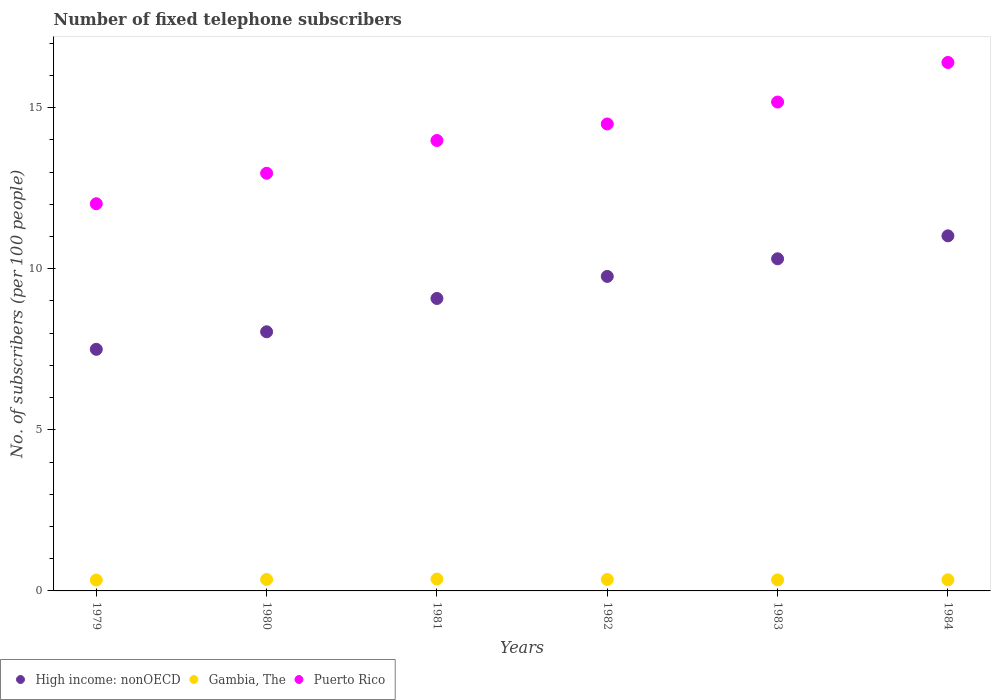Is the number of dotlines equal to the number of legend labels?
Your response must be concise. Yes. What is the number of fixed telephone subscribers in High income: nonOECD in 1979?
Your answer should be compact. 7.5. Across all years, what is the maximum number of fixed telephone subscribers in High income: nonOECD?
Your response must be concise. 11.02. Across all years, what is the minimum number of fixed telephone subscribers in Gambia, The?
Offer a very short reply. 0.34. In which year was the number of fixed telephone subscribers in Puerto Rico minimum?
Make the answer very short. 1979. What is the total number of fixed telephone subscribers in High income: nonOECD in the graph?
Provide a succinct answer. 55.71. What is the difference between the number of fixed telephone subscribers in High income: nonOECD in 1981 and that in 1983?
Your answer should be compact. -1.23. What is the difference between the number of fixed telephone subscribers in Gambia, The in 1979 and the number of fixed telephone subscribers in Puerto Rico in 1983?
Your answer should be compact. -14.83. What is the average number of fixed telephone subscribers in High income: nonOECD per year?
Your answer should be compact. 9.28. In the year 1980, what is the difference between the number of fixed telephone subscribers in High income: nonOECD and number of fixed telephone subscribers in Puerto Rico?
Give a very brief answer. -4.92. In how many years, is the number of fixed telephone subscribers in Puerto Rico greater than 9?
Your response must be concise. 6. What is the ratio of the number of fixed telephone subscribers in High income: nonOECD in 1979 to that in 1982?
Provide a short and direct response. 0.77. Is the number of fixed telephone subscribers in Gambia, The in 1979 less than that in 1982?
Ensure brevity in your answer.  Yes. Is the difference between the number of fixed telephone subscribers in High income: nonOECD in 1979 and 1982 greater than the difference between the number of fixed telephone subscribers in Puerto Rico in 1979 and 1982?
Give a very brief answer. Yes. What is the difference between the highest and the second highest number of fixed telephone subscribers in Puerto Rico?
Offer a very short reply. 1.23. What is the difference between the highest and the lowest number of fixed telephone subscribers in Gambia, The?
Make the answer very short. 0.03. In how many years, is the number of fixed telephone subscribers in Puerto Rico greater than the average number of fixed telephone subscribers in Puerto Rico taken over all years?
Provide a short and direct response. 3. Is the sum of the number of fixed telephone subscribers in High income: nonOECD in 1980 and 1984 greater than the maximum number of fixed telephone subscribers in Puerto Rico across all years?
Offer a very short reply. Yes. Is it the case that in every year, the sum of the number of fixed telephone subscribers in Gambia, The and number of fixed telephone subscribers in High income: nonOECD  is greater than the number of fixed telephone subscribers in Puerto Rico?
Offer a terse response. No. Does the number of fixed telephone subscribers in Puerto Rico monotonically increase over the years?
Provide a short and direct response. Yes. How many years are there in the graph?
Keep it short and to the point. 6. What is the difference between two consecutive major ticks on the Y-axis?
Ensure brevity in your answer.  5. Does the graph contain any zero values?
Your answer should be compact. No. Where does the legend appear in the graph?
Keep it short and to the point. Bottom left. How are the legend labels stacked?
Provide a succinct answer. Horizontal. What is the title of the graph?
Provide a succinct answer. Number of fixed telephone subscribers. What is the label or title of the X-axis?
Ensure brevity in your answer.  Years. What is the label or title of the Y-axis?
Offer a very short reply. No. of subscribers (per 100 people). What is the No. of subscribers (per 100 people) of High income: nonOECD in 1979?
Provide a succinct answer. 7.5. What is the No. of subscribers (per 100 people) in Gambia, The in 1979?
Your response must be concise. 0.34. What is the No. of subscribers (per 100 people) of Puerto Rico in 1979?
Ensure brevity in your answer.  12.02. What is the No. of subscribers (per 100 people) of High income: nonOECD in 1980?
Ensure brevity in your answer.  8.04. What is the No. of subscribers (per 100 people) of Gambia, The in 1980?
Your answer should be compact. 0.36. What is the No. of subscribers (per 100 people) of Puerto Rico in 1980?
Your answer should be very brief. 12.96. What is the No. of subscribers (per 100 people) of High income: nonOECD in 1981?
Your answer should be compact. 9.08. What is the No. of subscribers (per 100 people) in Gambia, The in 1981?
Your answer should be very brief. 0.37. What is the No. of subscribers (per 100 people) of Puerto Rico in 1981?
Your answer should be very brief. 13.98. What is the No. of subscribers (per 100 people) of High income: nonOECD in 1982?
Your answer should be very brief. 9.76. What is the No. of subscribers (per 100 people) in Gambia, The in 1982?
Offer a very short reply. 0.35. What is the No. of subscribers (per 100 people) of Puerto Rico in 1982?
Keep it short and to the point. 14.49. What is the No. of subscribers (per 100 people) in High income: nonOECD in 1983?
Ensure brevity in your answer.  10.31. What is the No. of subscribers (per 100 people) of Gambia, The in 1983?
Provide a succinct answer. 0.34. What is the No. of subscribers (per 100 people) of Puerto Rico in 1983?
Give a very brief answer. 15.17. What is the No. of subscribers (per 100 people) in High income: nonOECD in 1984?
Your answer should be compact. 11.02. What is the No. of subscribers (per 100 people) of Gambia, The in 1984?
Ensure brevity in your answer.  0.35. What is the No. of subscribers (per 100 people) of Puerto Rico in 1984?
Your answer should be compact. 16.4. Across all years, what is the maximum No. of subscribers (per 100 people) in High income: nonOECD?
Provide a short and direct response. 11.02. Across all years, what is the maximum No. of subscribers (per 100 people) of Gambia, The?
Offer a terse response. 0.37. Across all years, what is the maximum No. of subscribers (per 100 people) of Puerto Rico?
Your response must be concise. 16.4. Across all years, what is the minimum No. of subscribers (per 100 people) of High income: nonOECD?
Provide a succinct answer. 7.5. Across all years, what is the minimum No. of subscribers (per 100 people) of Gambia, The?
Provide a succinct answer. 0.34. Across all years, what is the minimum No. of subscribers (per 100 people) in Puerto Rico?
Offer a terse response. 12.02. What is the total No. of subscribers (per 100 people) in High income: nonOECD in the graph?
Make the answer very short. 55.71. What is the total No. of subscribers (per 100 people) in Gambia, The in the graph?
Provide a succinct answer. 2.1. What is the total No. of subscribers (per 100 people) in Puerto Rico in the graph?
Keep it short and to the point. 85.02. What is the difference between the No. of subscribers (per 100 people) of High income: nonOECD in 1979 and that in 1980?
Ensure brevity in your answer.  -0.54. What is the difference between the No. of subscribers (per 100 people) of Gambia, The in 1979 and that in 1980?
Keep it short and to the point. -0.02. What is the difference between the No. of subscribers (per 100 people) of Puerto Rico in 1979 and that in 1980?
Provide a succinct answer. -0.95. What is the difference between the No. of subscribers (per 100 people) of High income: nonOECD in 1979 and that in 1981?
Ensure brevity in your answer.  -1.58. What is the difference between the No. of subscribers (per 100 people) in Gambia, The in 1979 and that in 1981?
Keep it short and to the point. -0.03. What is the difference between the No. of subscribers (per 100 people) of Puerto Rico in 1979 and that in 1981?
Keep it short and to the point. -1.96. What is the difference between the No. of subscribers (per 100 people) of High income: nonOECD in 1979 and that in 1982?
Give a very brief answer. -2.26. What is the difference between the No. of subscribers (per 100 people) of Gambia, The in 1979 and that in 1982?
Ensure brevity in your answer.  -0.02. What is the difference between the No. of subscribers (per 100 people) in Puerto Rico in 1979 and that in 1982?
Your response must be concise. -2.48. What is the difference between the No. of subscribers (per 100 people) of High income: nonOECD in 1979 and that in 1983?
Your answer should be very brief. -2.81. What is the difference between the No. of subscribers (per 100 people) of Gambia, The in 1979 and that in 1983?
Your response must be concise. -0. What is the difference between the No. of subscribers (per 100 people) of Puerto Rico in 1979 and that in 1983?
Ensure brevity in your answer.  -3.16. What is the difference between the No. of subscribers (per 100 people) of High income: nonOECD in 1979 and that in 1984?
Make the answer very short. -3.52. What is the difference between the No. of subscribers (per 100 people) in Gambia, The in 1979 and that in 1984?
Provide a short and direct response. -0.01. What is the difference between the No. of subscribers (per 100 people) in Puerto Rico in 1979 and that in 1984?
Your answer should be very brief. -4.38. What is the difference between the No. of subscribers (per 100 people) of High income: nonOECD in 1980 and that in 1981?
Ensure brevity in your answer.  -1.03. What is the difference between the No. of subscribers (per 100 people) of Gambia, The in 1980 and that in 1981?
Make the answer very short. -0.01. What is the difference between the No. of subscribers (per 100 people) of Puerto Rico in 1980 and that in 1981?
Give a very brief answer. -1.02. What is the difference between the No. of subscribers (per 100 people) of High income: nonOECD in 1980 and that in 1982?
Keep it short and to the point. -1.72. What is the difference between the No. of subscribers (per 100 people) of Gambia, The in 1980 and that in 1982?
Your answer should be very brief. 0. What is the difference between the No. of subscribers (per 100 people) of Puerto Rico in 1980 and that in 1982?
Your answer should be very brief. -1.53. What is the difference between the No. of subscribers (per 100 people) of High income: nonOECD in 1980 and that in 1983?
Ensure brevity in your answer.  -2.27. What is the difference between the No. of subscribers (per 100 people) of Gambia, The in 1980 and that in 1983?
Offer a very short reply. 0.01. What is the difference between the No. of subscribers (per 100 people) in Puerto Rico in 1980 and that in 1983?
Keep it short and to the point. -2.21. What is the difference between the No. of subscribers (per 100 people) in High income: nonOECD in 1980 and that in 1984?
Keep it short and to the point. -2.98. What is the difference between the No. of subscribers (per 100 people) in Gambia, The in 1980 and that in 1984?
Offer a terse response. 0.01. What is the difference between the No. of subscribers (per 100 people) of Puerto Rico in 1980 and that in 1984?
Offer a very short reply. -3.44. What is the difference between the No. of subscribers (per 100 people) in High income: nonOECD in 1981 and that in 1982?
Ensure brevity in your answer.  -0.68. What is the difference between the No. of subscribers (per 100 people) of Gambia, The in 1981 and that in 1982?
Offer a terse response. 0.01. What is the difference between the No. of subscribers (per 100 people) in Puerto Rico in 1981 and that in 1982?
Offer a terse response. -0.51. What is the difference between the No. of subscribers (per 100 people) of High income: nonOECD in 1981 and that in 1983?
Your response must be concise. -1.23. What is the difference between the No. of subscribers (per 100 people) of Gambia, The in 1981 and that in 1983?
Your answer should be compact. 0.03. What is the difference between the No. of subscribers (per 100 people) of Puerto Rico in 1981 and that in 1983?
Your response must be concise. -1.19. What is the difference between the No. of subscribers (per 100 people) in High income: nonOECD in 1981 and that in 1984?
Ensure brevity in your answer.  -1.94. What is the difference between the No. of subscribers (per 100 people) of Gambia, The in 1981 and that in 1984?
Offer a terse response. 0.02. What is the difference between the No. of subscribers (per 100 people) in Puerto Rico in 1981 and that in 1984?
Ensure brevity in your answer.  -2.42. What is the difference between the No. of subscribers (per 100 people) in High income: nonOECD in 1982 and that in 1983?
Provide a short and direct response. -0.55. What is the difference between the No. of subscribers (per 100 people) of Gambia, The in 1982 and that in 1983?
Your answer should be very brief. 0.01. What is the difference between the No. of subscribers (per 100 people) in Puerto Rico in 1982 and that in 1983?
Offer a terse response. -0.68. What is the difference between the No. of subscribers (per 100 people) in High income: nonOECD in 1982 and that in 1984?
Provide a short and direct response. -1.26. What is the difference between the No. of subscribers (per 100 people) of Gambia, The in 1982 and that in 1984?
Ensure brevity in your answer.  0.01. What is the difference between the No. of subscribers (per 100 people) of Puerto Rico in 1982 and that in 1984?
Keep it short and to the point. -1.91. What is the difference between the No. of subscribers (per 100 people) in High income: nonOECD in 1983 and that in 1984?
Ensure brevity in your answer.  -0.71. What is the difference between the No. of subscribers (per 100 people) in Gambia, The in 1983 and that in 1984?
Your response must be concise. -0. What is the difference between the No. of subscribers (per 100 people) in Puerto Rico in 1983 and that in 1984?
Offer a very short reply. -1.23. What is the difference between the No. of subscribers (per 100 people) of High income: nonOECD in 1979 and the No. of subscribers (per 100 people) of Gambia, The in 1980?
Keep it short and to the point. 7.14. What is the difference between the No. of subscribers (per 100 people) in High income: nonOECD in 1979 and the No. of subscribers (per 100 people) in Puerto Rico in 1980?
Your answer should be very brief. -5.46. What is the difference between the No. of subscribers (per 100 people) in Gambia, The in 1979 and the No. of subscribers (per 100 people) in Puerto Rico in 1980?
Provide a succinct answer. -12.62. What is the difference between the No. of subscribers (per 100 people) in High income: nonOECD in 1979 and the No. of subscribers (per 100 people) in Gambia, The in 1981?
Offer a terse response. 7.13. What is the difference between the No. of subscribers (per 100 people) in High income: nonOECD in 1979 and the No. of subscribers (per 100 people) in Puerto Rico in 1981?
Make the answer very short. -6.48. What is the difference between the No. of subscribers (per 100 people) of Gambia, The in 1979 and the No. of subscribers (per 100 people) of Puerto Rico in 1981?
Provide a short and direct response. -13.64. What is the difference between the No. of subscribers (per 100 people) of High income: nonOECD in 1979 and the No. of subscribers (per 100 people) of Gambia, The in 1982?
Provide a short and direct response. 7.14. What is the difference between the No. of subscribers (per 100 people) in High income: nonOECD in 1979 and the No. of subscribers (per 100 people) in Puerto Rico in 1982?
Provide a short and direct response. -6.99. What is the difference between the No. of subscribers (per 100 people) of Gambia, The in 1979 and the No. of subscribers (per 100 people) of Puerto Rico in 1982?
Ensure brevity in your answer.  -14.15. What is the difference between the No. of subscribers (per 100 people) in High income: nonOECD in 1979 and the No. of subscribers (per 100 people) in Gambia, The in 1983?
Your answer should be compact. 7.16. What is the difference between the No. of subscribers (per 100 people) of High income: nonOECD in 1979 and the No. of subscribers (per 100 people) of Puerto Rico in 1983?
Give a very brief answer. -7.67. What is the difference between the No. of subscribers (per 100 people) in Gambia, The in 1979 and the No. of subscribers (per 100 people) in Puerto Rico in 1983?
Make the answer very short. -14.83. What is the difference between the No. of subscribers (per 100 people) of High income: nonOECD in 1979 and the No. of subscribers (per 100 people) of Gambia, The in 1984?
Keep it short and to the point. 7.15. What is the difference between the No. of subscribers (per 100 people) in High income: nonOECD in 1979 and the No. of subscribers (per 100 people) in Puerto Rico in 1984?
Provide a succinct answer. -8.9. What is the difference between the No. of subscribers (per 100 people) of Gambia, The in 1979 and the No. of subscribers (per 100 people) of Puerto Rico in 1984?
Give a very brief answer. -16.06. What is the difference between the No. of subscribers (per 100 people) in High income: nonOECD in 1980 and the No. of subscribers (per 100 people) in Gambia, The in 1981?
Offer a terse response. 7.67. What is the difference between the No. of subscribers (per 100 people) of High income: nonOECD in 1980 and the No. of subscribers (per 100 people) of Puerto Rico in 1981?
Your response must be concise. -5.94. What is the difference between the No. of subscribers (per 100 people) in Gambia, The in 1980 and the No. of subscribers (per 100 people) in Puerto Rico in 1981?
Offer a very short reply. -13.62. What is the difference between the No. of subscribers (per 100 people) in High income: nonOECD in 1980 and the No. of subscribers (per 100 people) in Gambia, The in 1982?
Your answer should be very brief. 7.69. What is the difference between the No. of subscribers (per 100 people) in High income: nonOECD in 1980 and the No. of subscribers (per 100 people) in Puerto Rico in 1982?
Provide a short and direct response. -6.45. What is the difference between the No. of subscribers (per 100 people) of Gambia, The in 1980 and the No. of subscribers (per 100 people) of Puerto Rico in 1982?
Offer a very short reply. -14.14. What is the difference between the No. of subscribers (per 100 people) of High income: nonOECD in 1980 and the No. of subscribers (per 100 people) of Gambia, The in 1983?
Your response must be concise. 7.7. What is the difference between the No. of subscribers (per 100 people) of High income: nonOECD in 1980 and the No. of subscribers (per 100 people) of Puerto Rico in 1983?
Ensure brevity in your answer.  -7.13. What is the difference between the No. of subscribers (per 100 people) of Gambia, The in 1980 and the No. of subscribers (per 100 people) of Puerto Rico in 1983?
Ensure brevity in your answer.  -14.82. What is the difference between the No. of subscribers (per 100 people) in High income: nonOECD in 1980 and the No. of subscribers (per 100 people) in Gambia, The in 1984?
Provide a succinct answer. 7.7. What is the difference between the No. of subscribers (per 100 people) in High income: nonOECD in 1980 and the No. of subscribers (per 100 people) in Puerto Rico in 1984?
Provide a short and direct response. -8.36. What is the difference between the No. of subscribers (per 100 people) of Gambia, The in 1980 and the No. of subscribers (per 100 people) of Puerto Rico in 1984?
Give a very brief answer. -16.05. What is the difference between the No. of subscribers (per 100 people) of High income: nonOECD in 1981 and the No. of subscribers (per 100 people) of Gambia, The in 1982?
Provide a short and direct response. 8.72. What is the difference between the No. of subscribers (per 100 people) in High income: nonOECD in 1981 and the No. of subscribers (per 100 people) in Puerto Rico in 1982?
Give a very brief answer. -5.42. What is the difference between the No. of subscribers (per 100 people) of Gambia, The in 1981 and the No. of subscribers (per 100 people) of Puerto Rico in 1982?
Ensure brevity in your answer.  -14.12. What is the difference between the No. of subscribers (per 100 people) of High income: nonOECD in 1981 and the No. of subscribers (per 100 people) of Gambia, The in 1983?
Provide a succinct answer. 8.73. What is the difference between the No. of subscribers (per 100 people) of High income: nonOECD in 1981 and the No. of subscribers (per 100 people) of Puerto Rico in 1983?
Ensure brevity in your answer.  -6.1. What is the difference between the No. of subscribers (per 100 people) of Gambia, The in 1981 and the No. of subscribers (per 100 people) of Puerto Rico in 1983?
Provide a succinct answer. -14.8. What is the difference between the No. of subscribers (per 100 people) in High income: nonOECD in 1981 and the No. of subscribers (per 100 people) in Gambia, The in 1984?
Offer a terse response. 8.73. What is the difference between the No. of subscribers (per 100 people) in High income: nonOECD in 1981 and the No. of subscribers (per 100 people) in Puerto Rico in 1984?
Your answer should be compact. -7.32. What is the difference between the No. of subscribers (per 100 people) in Gambia, The in 1981 and the No. of subscribers (per 100 people) in Puerto Rico in 1984?
Keep it short and to the point. -16.03. What is the difference between the No. of subscribers (per 100 people) of High income: nonOECD in 1982 and the No. of subscribers (per 100 people) of Gambia, The in 1983?
Keep it short and to the point. 9.42. What is the difference between the No. of subscribers (per 100 people) in High income: nonOECD in 1982 and the No. of subscribers (per 100 people) in Puerto Rico in 1983?
Provide a succinct answer. -5.41. What is the difference between the No. of subscribers (per 100 people) of Gambia, The in 1982 and the No. of subscribers (per 100 people) of Puerto Rico in 1983?
Give a very brief answer. -14.82. What is the difference between the No. of subscribers (per 100 people) in High income: nonOECD in 1982 and the No. of subscribers (per 100 people) in Gambia, The in 1984?
Your response must be concise. 9.42. What is the difference between the No. of subscribers (per 100 people) in High income: nonOECD in 1982 and the No. of subscribers (per 100 people) in Puerto Rico in 1984?
Provide a succinct answer. -6.64. What is the difference between the No. of subscribers (per 100 people) of Gambia, The in 1982 and the No. of subscribers (per 100 people) of Puerto Rico in 1984?
Give a very brief answer. -16.05. What is the difference between the No. of subscribers (per 100 people) of High income: nonOECD in 1983 and the No. of subscribers (per 100 people) of Gambia, The in 1984?
Provide a short and direct response. 9.96. What is the difference between the No. of subscribers (per 100 people) in High income: nonOECD in 1983 and the No. of subscribers (per 100 people) in Puerto Rico in 1984?
Your response must be concise. -6.09. What is the difference between the No. of subscribers (per 100 people) of Gambia, The in 1983 and the No. of subscribers (per 100 people) of Puerto Rico in 1984?
Your answer should be very brief. -16.06. What is the average No. of subscribers (per 100 people) of High income: nonOECD per year?
Give a very brief answer. 9.28. What is the average No. of subscribers (per 100 people) of Gambia, The per year?
Provide a short and direct response. 0.35. What is the average No. of subscribers (per 100 people) of Puerto Rico per year?
Ensure brevity in your answer.  14.17. In the year 1979, what is the difference between the No. of subscribers (per 100 people) of High income: nonOECD and No. of subscribers (per 100 people) of Gambia, The?
Keep it short and to the point. 7.16. In the year 1979, what is the difference between the No. of subscribers (per 100 people) of High income: nonOECD and No. of subscribers (per 100 people) of Puerto Rico?
Your response must be concise. -4.52. In the year 1979, what is the difference between the No. of subscribers (per 100 people) in Gambia, The and No. of subscribers (per 100 people) in Puerto Rico?
Your answer should be very brief. -11.68. In the year 1980, what is the difference between the No. of subscribers (per 100 people) of High income: nonOECD and No. of subscribers (per 100 people) of Gambia, The?
Keep it short and to the point. 7.69. In the year 1980, what is the difference between the No. of subscribers (per 100 people) in High income: nonOECD and No. of subscribers (per 100 people) in Puerto Rico?
Make the answer very short. -4.92. In the year 1980, what is the difference between the No. of subscribers (per 100 people) in Gambia, The and No. of subscribers (per 100 people) in Puerto Rico?
Offer a terse response. -12.61. In the year 1981, what is the difference between the No. of subscribers (per 100 people) of High income: nonOECD and No. of subscribers (per 100 people) of Gambia, The?
Make the answer very short. 8.71. In the year 1981, what is the difference between the No. of subscribers (per 100 people) in High income: nonOECD and No. of subscribers (per 100 people) in Puerto Rico?
Provide a short and direct response. -4.9. In the year 1981, what is the difference between the No. of subscribers (per 100 people) in Gambia, The and No. of subscribers (per 100 people) in Puerto Rico?
Provide a succinct answer. -13.61. In the year 1982, what is the difference between the No. of subscribers (per 100 people) in High income: nonOECD and No. of subscribers (per 100 people) in Gambia, The?
Offer a very short reply. 9.41. In the year 1982, what is the difference between the No. of subscribers (per 100 people) of High income: nonOECD and No. of subscribers (per 100 people) of Puerto Rico?
Your response must be concise. -4.73. In the year 1982, what is the difference between the No. of subscribers (per 100 people) in Gambia, The and No. of subscribers (per 100 people) in Puerto Rico?
Offer a very short reply. -14.14. In the year 1983, what is the difference between the No. of subscribers (per 100 people) of High income: nonOECD and No. of subscribers (per 100 people) of Gambia, The?
Offer a terse response. 9.97. In the year 1983, what is the difference between the No. of subscribers (per 100 people) of High income: nonOECD and No. of subscribers (per 100 people) of Puerto Rico?
Give a very brief answer. -4.86. In the year 1983, what is the difference between the No. of subscribers (per 100 people) of Gambia, The and No. of subscribers (per 100 people) of Puerto Rico?
Ensure brevity in your answer.  -14.83. In the year 1984, what is the difference between the No. of subscribers (per 100 people) of High income: nonOECD and No. of subscribers (per 100 people) of Gambia, The?
Keep it short and to the point. 10.67. In the year 1984, what is the difference between the No. of subscribers (per 100 people) of High income: nonOECD and No. of subscribers (per 100 people) of Puerto Rico?
Provide a succinct answer. -5.38. In the year 1984, what is the difference between the No. of subscribers (per 100 people) of Gambia, The and No. of subscribers (per 100 people) of Puerto Rico?
Offer a terse response. -16.06. What is the ratio of the No. of subscribers (per 100 people) in High income: nonOECD in 1979 to that in 1980?
Your response must be concise. 0.93. What is the ratio of the No. of subscribers (per 100 people) in Gambia, The in 1979 to that in 1980?
Give a very brief answer. 0.95. What is the ratio of the No. of subscribers (per 100 people) in Puerto Rico in 1979 to that in 1980?
Give a very brief answer. 0.93. What is the ratio of the No. of subscribers (per 100 people) of High income: nonOECD in 1979 to that in 1981?
Keep it short and to the point. 0.83. What is the ratio of the No. of subscribers (per 100 people) in Gambia, The in 1979 to that in 1981?
Offer a terse response. 0.92. What is the ratio of the No. of subscribers (per 100 people) in Puerto Rico in 1979 to that in 1981?
Offer a terse response. 0.86. What is the ratio of the No. of subscribers (per 100 people) in High income: nonOECD in 1979 to that in 1982?
Give a very brief answer. 0.77. What is the ratio of the No. of subscribers (per 100 people) in Gambia, The in 1979 to that in 1982?
Make the answer very short. 0.95. What is the ratio of the No. of subscribers (per 100 people) in Puerto Rico in 1979 to that in 1982?
Your answer should be compact. 0.83. What is the ratio of the No. of subscribers (per 100 people) in High income: nonOECD in 1979 to that in 1983?
Provide a succinct answer. 0.73. What is the ratio of the No. of subscribers (per 100 people) of Puerto Rico in 1979 to that in 1983?
Make the answer very short. 0.79. What is the ratio of the No. of subscribers (per 100 people) of High income: nonOECD in 1979 to that in 1984?
Your answer should be very brief. 0.68. What is the ratio of the No. of subscribers (per 100 people) of Gambia, The in 1979 to that in 1984?
Your response must be concise. 0.98. What is the ratio of the No. of subscribers (per 100 people) in Puerto Rico in 1979 to that in 1984?
Your response must be concise. 0.73. What is the ratio of the No. of subscribers (per 100 people) of High income: nonOECD in 1980 to that in 1981?
Make the answer very short. 0.89. What is the ratio of the No. of subscribers (per 100 people) of Gambia, The in 1980 to that in 1981?
Give a very brief answer. 0.97. What is the ratio of the No. of subscribers (per 100 people) of Puerto Rico in 1980 to that in 1981?
Give a very brief answer. 0.93. What is the ratio of the No. of subscribers (per 100 people) in High income: nonOECD in 1980 to that in 1982?
Your answer should be very brief. 0.82. What is the ratio of the No. of subscribers (per 100 people) of Gambia, The in 1980 to that in 1982?
Offer a terse response. 1. What is the ratio of the No. of subscribers (per 100 people) in Puerto Rico in 1980 to that in 1982?
Provide a short and direct response. 0.89. What is the ratio of the No. of subscribers (per 100 people) in High income: nonOECD in 1980 to that in 1983?
Your answer should be compact. 0.78. What is the ratio of the No. of subscribers (per 100 people) of Gambia, The in 1980 to that in 1983?
Offer a terse response. 1.04. What is the ratio of the No. of subscribers (per 100 people) of Puerto Rico in 1980 to that in 1983?
Offer a very short reply. 0.85. What is the ratio of the No. of subscribers (per 100 people) of High income: nonOECD in 1980 to that in 1984?
Ensure brevity in your answer.  0.73. What is the ratio of the No. of subscribers (per 100 people) of Gambia, The in 1980 to that in 1984?
Your answer should be very brief. 1.03. What is the ratio of the No. of subscribers (per 100 people) of Puerto Rico in 1980 to that in 1984?
Your answer should be very brief. 0.79. What is the ratio of the No. of subscribers (per 100 people) in High income: nonOECD in 1981 to that in 1982?
Provide a succinct answer. 0.93. What is the ratio of the No. of subscribers (per 100 people) of Gambia, The in 1981 to that in 1982?
Your response must be concise. 1.04. What is the ratio of the No. of subscribers (per 100 people) of Puerto Rico in 1981 to that in 1982?
Offer a very short reply. 0.96. What is the ratio of the No. of subscribers (per 100 people) in High income: nonOECD in 1981 to that in 1983?
Your answer should be compact. 0.88. What is the ratio of the No. of subscribers (per 100 people) in Gambia, The in 1981 to that in 1983?
Give a very brief answer. 1.08. What is the ratio of the No. of subscribers (per 100 people) of Puerto Rico in 1981 to that in 1983?
Provide a short and direct response. 0.92. What is the ratio of the No. of subscribers (per 100 people) in High income: nonOECD in 1981 to that in 1984?
Offer a terse response. 0.82. What is the ratio of the No. of subscribers (per 100 people) of Gambia, The in 1981 to that in 1984?
Give a very brief answer. 1.07. What is the ratio of the No. of subscribers (per 100 people) of Puerto Rico in 1981 to that in 1984?
Offer a terse response. 0.85. What is the ratio of the No. of subscribers (per 100 people) of High income: nonOECD in 1982 to that in 1983?
Offer a very short reply. 0.95. What is the ratio of the No. of subscribers (per 100 people) in Gambia, The in 1982 to that in 1983?
Offer a terse response. 1.04. What is the ratio of the No. of subscribers (per 100 people) in Puerto Rico in 1982 to that in 1983?
Provide a succinct answer. 0.96. What is the ratio of the No. of subscribers (per 100 people) in High income: nonOECD in 1982 to that in 1984?
Give a very brief answer. 0.89. What is the ratio of the No. of subscribers (per 100 people) in Gambia, The in 1982 to that in 1984?
Keep it short and to the point. 1.03. What is the ratio of the No. of subscribers (per 100 people) in Puerto Rico in 1982 to that in 1984?
Provide a succinct answer. 0.88. What is the ratio of the No. of subscribers (per 100 people) in High income: nonOECD in 1983 to that in 1984?
Your response must be concise. 0.94. What is the ratio of the No. of subscribers (per 100 people) in Gambia, The in 1983 to that in 1984?
Provide a short and direct response. 0.99. What is the ratio of the No. of subscribers (per 100 people) of Puerto Rico in 1983 to that in 1984?
Make the answer very short. 0.93. What is the difference between the highest and the second highest No. of subscribers (per 100 people) of High income: nonOECD?
Your answer should be compact. 0.71. What is the difference between the highest and the second highest No. of subscribers (per 100 people) of Gambia, The?
Keep it short and to the point. 0.01. What is the difference between the highest and the second highest No. of subscribers (per 100 people) of Puerto Rico?
Your answer should be very brief. 1.23. What is the difference between the highest and the lowest No. of subscribers (per 100 people) of High income: nonOECD?
Provide a succinct answer. 3.52. What is the difference between the highest and the lowest No. of subscribers (per 100 people) of Gambia, The?
Give a very brief answer. 0.03. What is the difference between the highest and the lowest No. of subscribers (per 100 people) of Puerto Rico?
Your answer should be very brief. 4.38. 